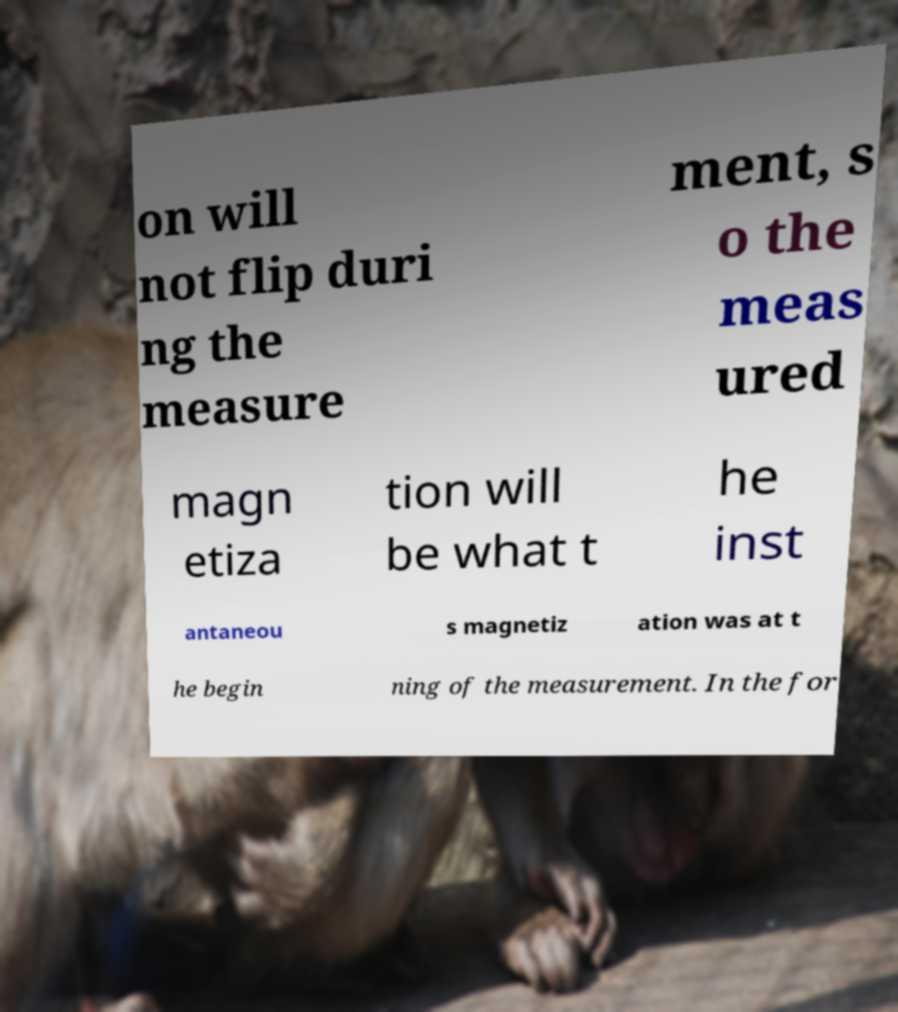Please read and relay the text visible in this image. What does it say? on will not flip duri ng the measure ment, s o the meas ured magn etiza tion will be what t he inst antaneou s magnetiz ation was at t he begin ning of the measurement. In the for 